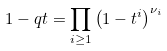<formula> <loc_0><loc_0><loc_500><loc_500>1 - q t = \prod _ { i \geq 1 } \left ( { 1 - t ^ { i } } \right ) ^ { \nu _ { i } }</formula> 